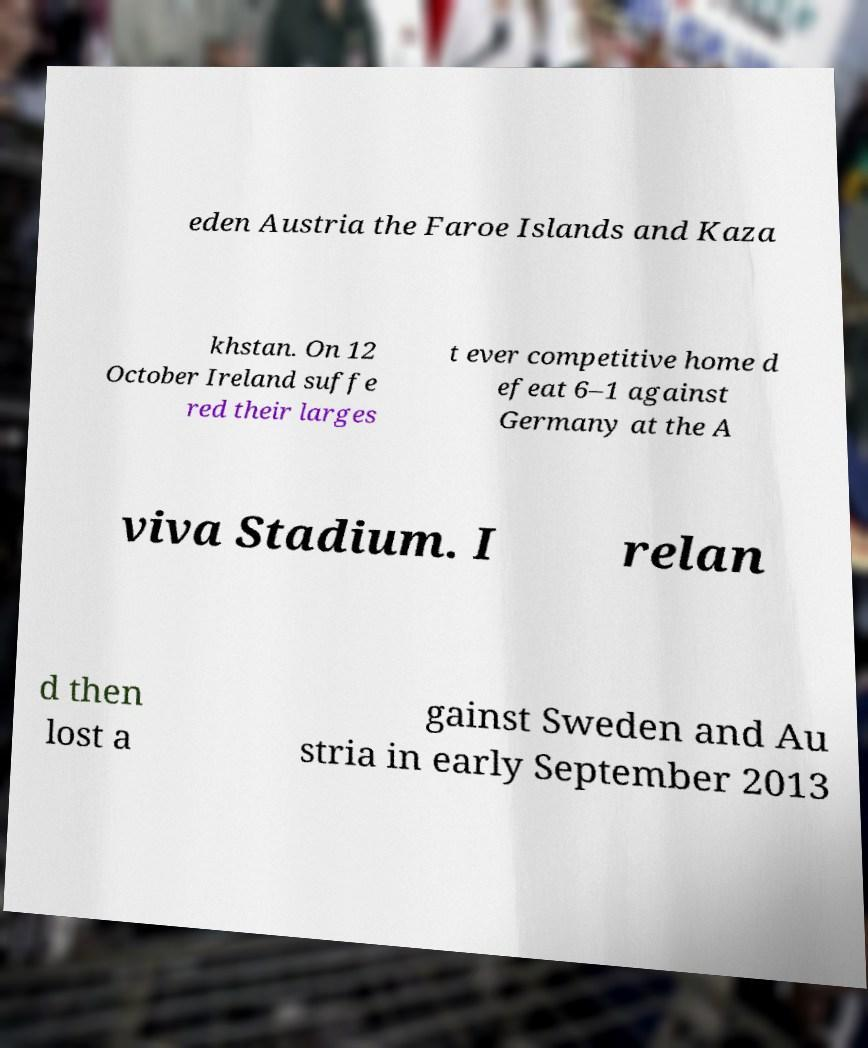Please read and relay the text visible in this image. What does it say? eden Austria the Faroe Islands and Kaza khstan. On 12 October Ireland suffe red their larges t ever competitive home d efeat 6–1 against Germany at the A viva Stadium. I relan d then lost a gainst Sweden and Au stria in early September 2013 